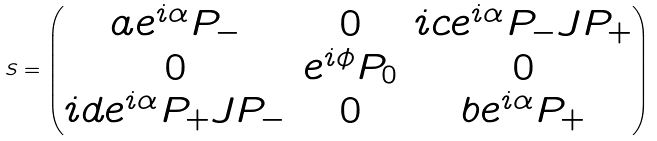<formula> <loc_0><loc_0><loc_500><loc_500>S = \begin{pmatrix} a e ^ { i \alpha } P _ { - } & 0 & i c e ^ { i \alpha } P _ { - } J P _ { + } \\ 0 & e ^ { i \phi } P _ { 0 } & 0 \\ i d e ^ { i \alpha } P _ { + } J P _ { - } & 0 & b e ^ { i \alpha } P _ { + } \end{pmatrix}</formula> 